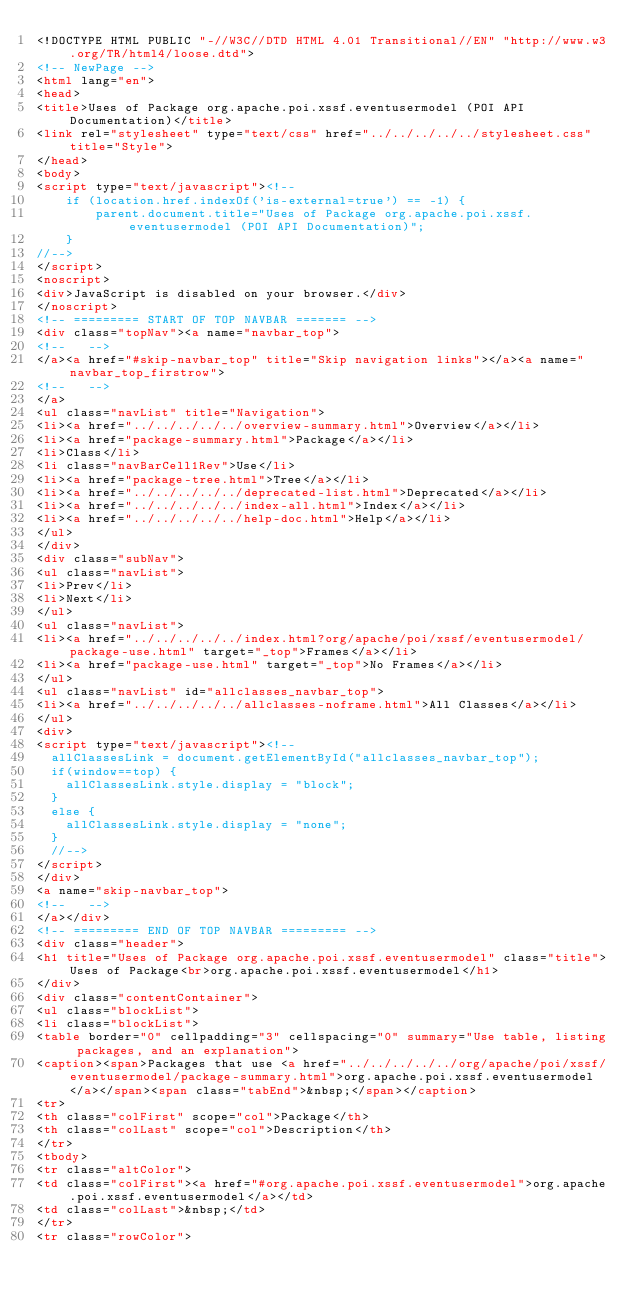Convert code to text. <code><loc_0><loc_0><loc_500><loc_500><_HTML_><!DOCTYPE HTML PUBLIC "-//W3C//DTD HTML 4.01 Transitional//EN" "http://www.w3.org/TR/html4/loose.dtd">
<!-- NewPage -->
<html lang="en">
<head>
<title>Uses of Package org.apache.poi.xssf.eventusermodel (POI API Documentation)</title>
<link rel="stylesheet" type="text/css" href="../../../../../stylesheet.css" title="Style">
</head>
<body>
<script type="text/javascript"><!--
    if (location.href.indexOf('is-external=true') == -1) {
        parent.document.title="Uses of Package org.apache.poi.xssf.eventusermodel (POI API Documentation)";
    }
//-->
</script>
<noscript>
<div>JavaScript is disabled on your browser.</div>
</noscript>
<!-- ========= START OF TOP NAVBAR ======= -->
<div class="topNav"><a name="navbar_top">
<!--   -->
</a><a href="#skip-navbar_top" title="Skip navigation links"></a><a name="navbar_top_firstrow">
<!--   -->
</a>
<ul class="navList" title="Navigation">
<li><a href="../../../../../overview-summary.html">Overview</a></li>
<li><a href="package-summary.html">Package</a></li>
<li>Class</li>
<li class="navBarCell1Rev">Use</li>
<li><a href="package-tree.html">Tree</a></li>
<li><a href="../../../../../deprecated-list.html">Deprecated</a></li>
<li><a href="../../../../../index-all.html">Index</a></li>
<li><a href="../../../../../help-doc.html">Help</a></li>
</ul>
</div>
<div class="subNav">
<ul class="navList">
<li>Prev</li>
<li>Next</li>
</ul>
<ul class="navList">
<li><a href="../../../../../index.html?org/apache/poi/xssf/eventusermodel/package-use.html" target="_top">Frames</a></li>
<li><a href="package-use.html" target="_top">No Frames</a></li>
</ul>
<ul class="navList" id="allclasses_navbar_top">
<li><a href="../../../../../allclasses-noframe.html">All Classes</a></li>
</ul>
<div>
<script type="text/javascript"><!--
  allClassesLink = document.getElementById("allclasses_navbar_top");
  if(window==top) {
    allClassesLink.style.display = "block";
  }
  else {
    allClassesLink.style.display = "none";
  }
  //-->
</script>
</div>
<a name="skip-navbar_top">
<!--   -->
</a></div>
<!-- ========= END OF TOP NAVBAR ========= -->
<div class="header">
<h1 title="Uses of Package org.apache.poi.xssf.eventusermodel" class="title">Uses of Package<br>org.apache.poi.xssf.eventusermodel</h1>
</div>
<div class="contentContainer">
<ul class="blockList">
<li class="blockList">
<table border="0" cellpadding="3" cellspacing="0" summary="Use table, listing packages, and an explanation">
<caption><span>Packages that use <a href="../../../../../org/apache/poi/xssf/eventusermodel/package-summary.html">org.apache.poi.xssf.eventusermodel</a></span><span class="tabEnd">&nbsp;</span></caption>
<tr>
<th class="colFirst" scope="col">Package</th>
<th class="colLast" scope="col">Description</th>
</tr>
<tbody>
<tr class="altColor">
<td class="colFirst"><a href="#org.apache.poi.xssf.eventusermodel">org.apache.poi.xssf.eventusermodel</a></td>
<td class="colLast">&nbsp;</td>
</tr>
<tr class="rowColor"></code> 